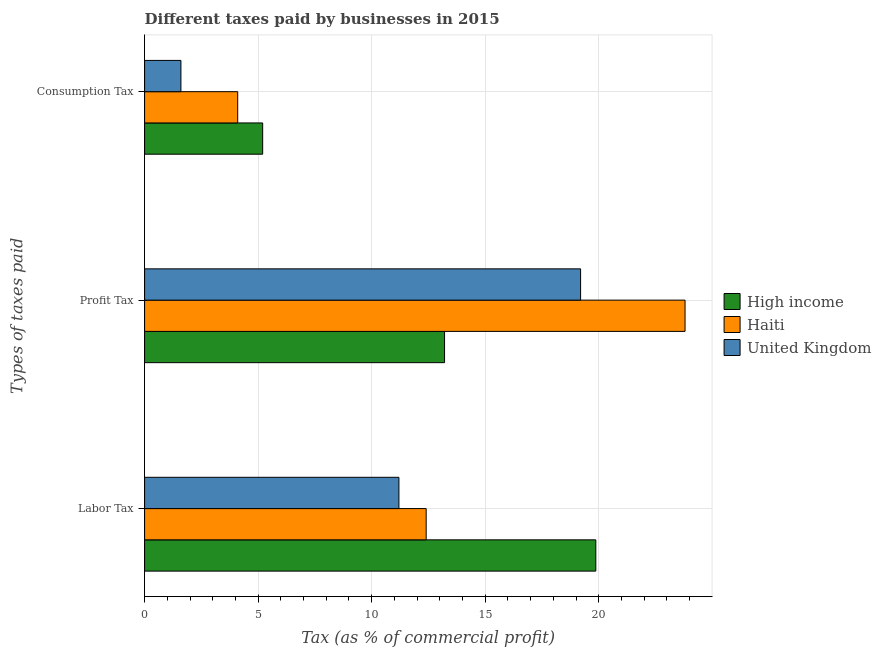How many bars are there on the 2nd tick from the bottom?
Offer a very short reply. 3. What is the label of the 3rd group of bars from the top?
Give a very brief answer. Labor Tax. Across all countries, what is the minimum percentage of profit tax?
Provide a succinct answer. 13.21. In which country was the percentage of labor tax maximum?
Give a very brief answer. High income. In which country was the percentage of labor tax minimum?
Keep it short and to the point. United Kingdom. What is the total percentage of consumption tax in the graph?
Offer a terse response. 10.9. What is the difference between the percentage of labor tax in Haiti and that in United Kingdom?
Make the answer very short. 1.2. What is the difference between the percentage of labor tax in United Kingdom and the percentage of consumption tax in High income?
Ensure brevity in your answer.  6. What is the average percentage of consumption tax per country?
Provide a short and direct response. 3.63. In how many countries, is the percentage of profit tax greater than 19 %?
Your answer should be very brief. 2. What is the ratio of the percentage of profit tax in United Kingdom to that in Haiti?
Make the answer very short. 0.81. Is the difference between the percentage of labor tax in United Kingdom and Haiti greater than the difference between the percentage of consumption tax in United Kingdom and Haiti?
Offer a terse response. Yes. What is the difference between the highest and the second highest percentage of labor tax?
Keep it short and to the point. 7.47. What is the difference between the highest and the lowest percentage of profit tax?
Make the answer very short. 10.59. What does the 1st bar from the top in Labor Tax represents?
Your answer should be very brief. United Kingdom. What does the 3rd bar from the bottom in Profit Tax represents?
Make the answer very short. United Kingdom. Is it the case that in every country, the sum of the percentage of labor tax and percentage of profit tax is greater than the percentage of consumption tax?
Offer a very short reply. Yes. Are the values on the major ticks of X-axis written in scientific E-notation?
Your response must be concise. No. Where does the legend appear in the graph?
Make the answer very short. Center right. How many legend labels are there?
Your answer should be compact. 3. How are the legend labels stacked?
Give a very brief answer. Vertical. What is the title of the graph?
Provide a short and direct response. Different taxes paid by businesses in 2015. Does "Morocco" appear as one of the legend labels in the graph?
Offer a terse response. No. What is the label or title of the X-axis?
Offer a terse response. Tax (as % of commercial profit). What is the label or title of the Y-axis?
Offer a very short reply. Types of taxes paid. What is the Tax (as % of commercial profit) of High income in Labor Tax?
Provide a short and direct response. 19.87. What is the Tax (as % of commercial profit) of Haiti in Labor Tax?
Your answer should be very brief. 12.4. What is the Tax (as % of commercial profit) in United Kingdom in Labor Tax?
Offer a terse response. 11.2. What is the Tax (as % of commercial profit) in High income in Profit Tax?
Provide a succinct answer. 13.21. What is the Tax (as % of commercial profit) of Haiti in Profit Tax?
Keep it short and to the point. 23.8. Across all Types of taxes paid, what is the maximum Tax (as % of commercial profit) in High income?
Your answer should be compact. 19.87. Across all Types of taxes paid, what is the maximum Tax (as % of commercial profit) in Haiti?
Offer a very short reply. 23.8. Across all Types of taxes paid, what is the maximum Tax (as % of commercial profit) of United Kingdom?
Ensure brevity in your answer.  19.2. Across all Types of taxes paid, what is the minimum Tax (as % of commercial profit) of High income?
Offer a terse response. 5.2. What is the total Tax (as % of commercial profit) of High income in the graph?
Offer a terse response. 38.28. What is the total Tax (as % of commercial profit) of Haiti in the graph?
Give a very brief answer. 40.3. What is the total Tax (as % of commercial profit) of United Kingdom in the graph?
Offer a terse response. 32. What is the difference between the Tax (as % of commercial profit) of High income in Labor Tax and that in Profit Tax?
Your answer should be very brief. 6.66. What is the difference between the Tax (as % of commercial profit) in Haiti in Labor Tax and that in Profit Tax?
Make the answer very short. -11.4. What is the difference between the Tax (as % of commercial profit) of High income in Labor Tax and that in Consumption Tax?
Your response must be concise. 14.67. What is the difference between the Tax (as % of commercial profit) in United Kingdom in Labor Tax and that in Consumption Tax?
Offer a very short reply. 9.6. What is the difference between the Tax (as % of commercial profit) in High income in Profit Tax and that in Consumption Tax?
Give a very brief answer. 8.01. What is the difference between the Tax (as % of commercial profit) in High income in Labor Tax and the Tax (as % of commercial profit) in Haiti in Profit Tax?
Make the answer very short. -3.93. What is the difference between the Tax (as % of commercial profit) of High income in Labor Tax and the Tax (as % of commercial profit) of United Kingdom in Profit Tax?
Give a very brief answer. 0.67. What is the difference between the Tax (as % of commercial profit) of Haiti in Labor Tax and the Tax (as % of commercial profit) of United Kingdom in Profit Tax?
Make the answer very short. -6.8. What is the difference between the Tax (as % of commercial profit) in High income in Labor Tax and the Tax (as % of commercial profit) in Haiti in Consumption Tax?
Provide a succinct answer. 15.77. What is the difference between the Tax (as % of commercial profit) of High income in Labor Tax and the Tax (as % of commercial profit) of United Kingdom in Consumption Tax?
Your answer should be very brief. 18.27. What is the difference between the Tax (as % of commercial profit) of Haiti in Labor Tax and the Tax (as % of commercial profit) of United Kingdom in Consumption Tax?
Make the answer very short. 10.8. What is the difference between the Tax (as % of commercial profit) in High income in Profit Tax and the Tax (as % of commercial profit) in Haiti in Consumption Tax?
Provide a short and direct response. 9.11. What is the difference between the Tax (as % of commercial profit) in High income in Profit Tax and the Tax (as % of commercial profit) in United Kingdom in Consumption Tax?
Ensure brevity in your answer.  11.61. What is the average Tax (as % of commercial profit) in High income per Types of taxes paid?
Ensure brevity in your answer.  12.76. What is the average Tax (as % of commercial profit) of Haiti per Types of taxes paid?
Give a very brief answer. 13.43. What is the average Tax (as % of commercial profit) in United Kingdom per Types of taxes paid?
Your answer should be very brief. 10.67. What is the difference between the Tax (as % of commercial profit) in High income and Tax (as % of commercial profit) in Haiti in Labor Tax?
Provide a short and direct response. 7.47. What is the difference between the Tax (as % of commercial profit) in High income and Tax (as % of commercial profit) in United Kingdom in Labor Tax?
Your answer should be compact. 8.67. What is the difference between the Tax (as % of commercial profit) of High income and Tax (as % of commercial profit) of Haiti in Profit Tax?
Give a very brief answer. -10.59. What is the difference between the Tax (as % of commercial profit) in High income and Tax (as % of commercial profit) in United Kingdom in Profit Tax?
Ensure brevity in your answer.  -5.99. What is the difference between the Tax (as % of commercial profit) of High income and Tax (as % of commercial profit) of United Kingdom in Consumption Tax?
Your answer should be very brief. 3.6. What is the difference between the Tax (as % of commercial profit) in Haiti and Tax (as % of commercial profit) in United Kingdom in Consumption Tax?
Offer a very short reply. 2.5. What is the ratio of the Tax (as % of commercial profit) in High income in Labor Tax to that in Profit Tax?
Offer a very short reply. 1.5. What is the ratio of the Tax (as % of commercial profit) in Haiti in Labor Tax to that in Profit Tax?
Make the answer very short. 0.52. What is the ratio of the Tax (as % of commercial profit) of United Kingdom in Labor Tax to that in Profit Tax?
Provide a short and direct response. 0.58. What is the ratio of the Tax (as % of commercial profit) of High income in Labor Tax to that in Consumption Tax?
Make the answer very short. 3.82. What is the ratio of the Tax (as % of commercial profit) of Haiti in Labor Tax to that in Consumption Tax?
Ensure brevity in your answer.  3.02. What is the ratio of the Tax (as % of commercial profit) in United Kingdom in Labor Tax to that in Consumption Tax?
Offer a terse response. 7. What is the ratio of the Tax (as % of commercial profit) of High income in Profit Tax to that in Consumption Tax?
Offer a very short reply. 2.54. What is the ratio of the Tax (as % of commercial profit) in Haiti in Profit Tax to that in Consumption Tax?
Keep it short and to the point. 5.8. What is the difference between the highest and the second highest Tax (as % of commercial profit) in High income?
Provide a short and direct response. 6.66. What is the difference between the highest and the second highest Tax (as % of commercial profit) in Haiti?
Provide a succinct answer. 11.4. What is the difference between the highest and the lowest Tax (as % of commercial profit) in High income?
Your answer should be compact. 14.67. What is the difference between the highest and the lowest Tax (as % of commercial profit) of United Kingdom?
Make the answer very short. 17.6. 